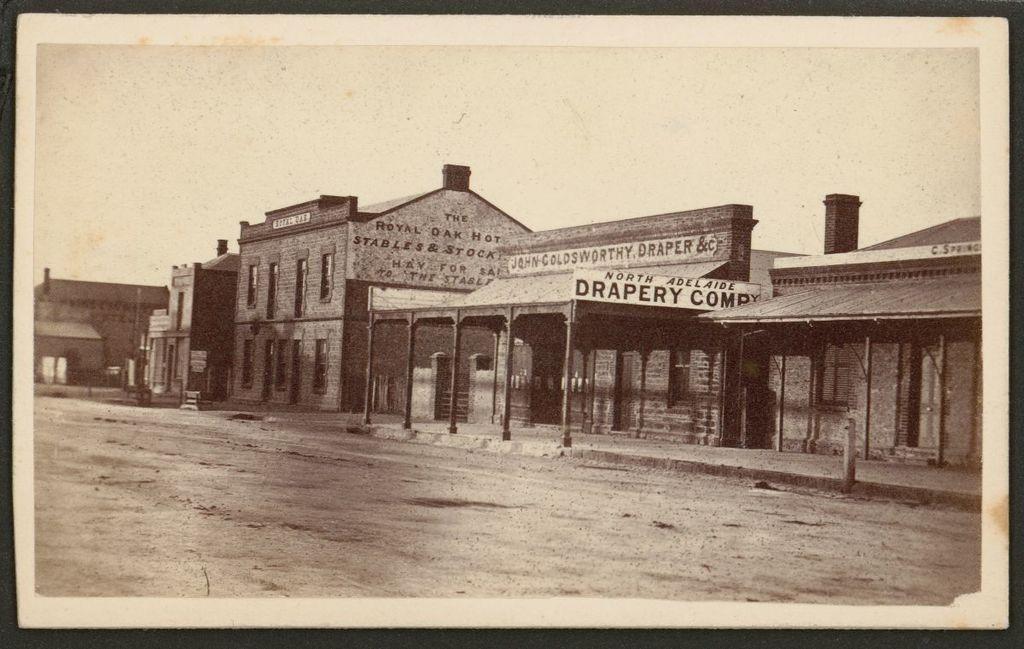Could you give a brief overview of what you see in this image? In this picture we can see few houses and hoardings, and it is a black and white photography. 